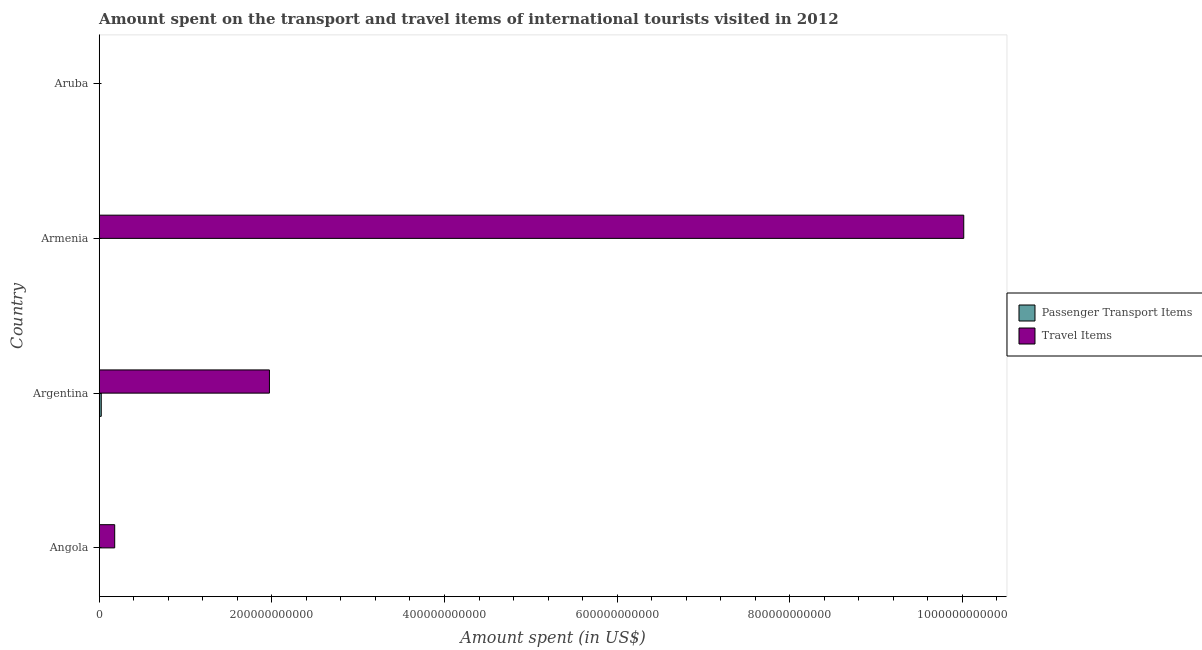How many different coloured bars are there?
Offer a terse response. 2. Are the number of bars per tick equal to the number of legend labels?
Your answer should be very brief. Yes. How many bars are there on the 4th tick from the bottom?
Ensure brevity in your answer.  2. What is the amount spent in travel items in Angola?
Offer a very short reply. 1.79e+1. Across all countries, what is the maximum amount spent in travel items?
Make the answer very short. 1.00e+12. Across all countries, what is the minimum amount spent in travel items?
Your answer should be compact. 7.50e+07. In which country was the amount spent in travel items maximum?
Give a very brief answer. Armenia. In which country was the amount spent in travel items minimum?
Ensure brevity in your answer.  Aruba. What is the total amount spent on passenger transport items in the graph?
Give a very brief answer. 2.57e+09. What is the difference between the amount spent in travel items in Angola and that in Aruba?
Your response must be concise. 1.79e+1. What is the difference between the amount spent on passenger transport items in Angola and the amount spent in travel items in Armenia?
Ensure brevity in your answer.  -1.00e+12. What is the average amount spent in travel items per country?
Your answer should be very brief. 3.04e+11. What is the difference between the amount spent on passenger transport items and amount spent in travel items in Armenia?
Ensure brevity in your answer.  -1.00e+12. What is the ratio of the amount spent on passenger transport items in Armenia to that in Aruba?
Provide a short and direct response. 3.74. Is the amount spent on passenger transport items in Angola less than that in Aruba?
Offer a terse response. No. Is the difference between the amount spent in travel items in Angola and Argentina greater than the difference between the amount spent on passenger transport items in Angola and Argentina?
Offer a very short reply. No. What is the difference between the highest and the second highest amount spent on passenger transport items?
Make the answer very short. 2.22e+09. What is the difference between the highest and the lowest amount spent in travel items?
Keep it short and to the point. 1.00e+12. In how many countries, is the amount spent in travel items greater than the average amount spent in travel items taken over all countries?
Provide a short and direct response. 1. Is the sum of the amount spent in travel items in Armenia and Aruba greater than the maximum amount spent on passenger transport items across all countries?
Keep it short and to the point. Yes. What does the 2nd bar from the top in Aruba represents?
Your response must be concise. Passenger Transport Items. What does the 1st bar from the bottom in Angola represents?
Provide a short and direct response. Passenger Transport Items. How many bars are there?
Your answer should be compact. 8. Are all the bars in the graph horizontal?
Ensure brevity in your answer.  Yes. What is the difference between two consecutive major ticks on the X-axis?
Your answer should be very brief. 2.00e+11. Are the values on the major ticks of X-axis written in scientific E-notation?
Offer a very short reply. No. Where does the legend appear in the graph?
Your response must be concise. Center right. How many legend labels are there?
Your response must be concise. 2. What is the title of the graph?
Give a very brief answer. Amount spent on the transport and travel items of international tourists visited in 2012. Does "Non-pregnant women" appear as one of the legend labels in the graph?
Provide a succinct answer. No. What is the label or title of the X-axis?
Make the answer very short. Amount spent (in US$). What is the label or title of the Y-axis?
Provide a short and direct response. Country. What is the Amount spent (in US$) of Passenger Transport Items in Angola?
Provide a short and direct response. 1.33e+08. What is the Amount spent (in US$) in Travel Items in Angola?
Your response must be concise. 1.79e+1. What is the Amount spent (in US$) of Passenger Transport Items in Argentina?
Offer a terse response. 2.35e+09. What is the Amount spent (in US$) in Travel Items in Argentina?
Make the answer very short. 1.97e+11. What is the Amount spent (in US$) in Passenger Transport Items in Armenia?
Your answer should be very brief. 7.10e+07. What is the Amount spent (in US$) of Travel Items in Armenia?
Your answer should be very brief. 1.00e+12. What is the Amount spent (in US$) in Passenger Transport Items in Aruba?
Offer a terse response. 1.90e+07. What is the Amount spent (in US$) in Travel Items in Aruba?
Keep it short and to the point. 7.50e+07. Across all countries, what is the maximum Amount spent (in US$) of Passenger Transport Items?
Provide a succinct answer. 2.35e+09. Across all countries, what is the maximum Amount spent (in US$) of Travel Items?
Provide a succinct answer. 1.00e+12. Across all countries, what is the minimum Amount spent (in US$) in Passenger Transport Items?
Make the answer very short. 1.90e+07. Across all countries, what is the minimum Amount spent (in US$) of Travel Items?
Provide a short and direct response. 7.50e+07. What is the total Amount spent (in US$) of Passenger Transport Items in the graph?
Provide a succinct answer. 2.57e+09. What is the total Amount spent (in US$) of Travel Items in the graph?
Offer a terse response. 1.22e+12. What is the difference between the Amount spent (in US$) in Passenger Transport Items in Angola and that in Argentina?
Your answer should be very brief. -2.22e+09. What is the difference between the Amount spent (in US$) in Travel Items in Angola and that in Argentina?
Provide a short and direct response. -1.79e+11. What is the difference between the Amount spent (in US$) of Passenger Transport Items in Angola and that in Armenia?
Offer a very short reply. 6.20e+07. What is the difference between the Amount spent (in US$) in Travel Items in Angola and that in Armenia?
Make the answer very short. -9.84e+11. What is the difference between the Amount spent (in US$) of Passenger Transport Items in Angola and that in Aruba?
Offer a terse response. 1.14e+08. What is the difference between the Amount spent (in US$) of Travel Items in Angola and that in Aruba?
Offer a terse response. 1.79e+1. What is the difference between the Amount spent (in US$) of Passenger Transport Items in Argentina and that in Armenia?
Ensure brevity in your answer.  2.28e+09. What is the difference between the Amount spent (in US$) in Travel Items in Argentina and that in Armenia?
Provide a succinct answer. -8.04e+11. What is the difference between the Amount spent (in US$) in Passenger Transport Items in Argentina and that in Aruba?
Provide a succinct answer. 2.33e+09. What is the difference between the Amount spent (in US$) in Travel Items in Argentina and that in Aruba?
Your response must be concise. 1.97e+11. What is the difference between the Amount spent (in US$) in Passenger Transport Items in Armenia and that in Aruba?
Offer a very short reply. 5.20e+07. What is the difference between the Amount spent (in US$) of Travel Items in Armenia and that in Aruba?
Offer a very short reply. 1.00e+12. What is the difference between the Amount spent (in US$) of Passenger Transport Items in Angola and the Amount spent (in US$) of Travel Items in Argentina?
Your response must be concise. -1.97e+11. What is the difference between the Amount spent (in US$) of Passenger Transport Items in Angola and the Amount spent (in US$) of Travel Items in Armenia?
Make the answer very short. -1.00e+12. What is the difference between the Amount spent (in US$) of Passenger Transport Items in Angola and the Amount spent (in US$) of Travel Items in Aruba?
Make the answer very short. 5.80e+07. What is the difference between the Amount spent (in US$) in Passenger Transport Items in Argentina and the Amount spent (in US$) in Travel Items in Armenia?
Make the answer very short. -9.99e+11. What is the difference between the Amount spent (in US$) of Passenger Transport Items in Argentina and the Amount spent (in US$) of Travel Items in Aruba?
Provide a succinct answer. 2.28e+09. What is the average Amount spent (in US$) of Passenger Transport Items per country?
Give a very brief answer. 6.43e+08. What is the average Amount spent (in US$) of Travel Items per country?
Make the answer very short. 3.04e+11. What is the difference between the Amount spent (in US$) of Passenger Transport Items and Amount spent (in US$) of Travel Items in Angola?
Your answer should be compact. -1.78e+1. What is the difference between the Amount spent (in US$) in Passenger Transport Items and Amount spent (in US$) in Travel Items in Argentina?
Your answer should be compact. -1.95e+11. What is the difference between the Amount spent (in US$) in Passenger Transport Items and Amount spent (in US$) in Travel Items in Armenia?
Ensure brevity in your answer.  -1.00e+12. What is the difference between the Amount spent (in US$) in Passenger Transport Items and Amount spent (in US$) in Travel Items in Aruba?
Your answer should be compact. -5.60e+07. What is the ratio of the Amount spent (in US$) of Passenger Transport Items in Angola to that in Argentina?
Your answer should be very brief. 0.06. What is the ratio of the Amount spent (in US$) of Travel Items in Angola to that in Argentina?
Your answer should be compact. 0.09. What is the ratio of the Amount spent (in US$) of Passenger Transport Items in Angola to that in Armenia?
Ensure brevity in your answer.  1.87. What is the ratio of the Amount spent (in US$) in Travel Items in Angola to that in Armenia?
Offer a terse response. 0.02. What is the ratio of the Amount spent (in US$) in Travel Items in Angola to that in Aruba?
Your answer should be compact. 239.23. What is the ratio of the Amount spent (in US$) of Passenger Transport Items in Argentina to that in Armenia?
Offer a very short reply. 33.1. What is the ratio of the Amount spent (in US$) in Travel Items in Argentina to that in Armenia?
Offer a very short reply. 0.2. What is the ratio of the Amount spent (in US$) in Passenger Transport Items in Argentina to that in Aruba?
Your answer should be compact. 123.68. What is the ratio of the Amount spent (in US$) in Travel Items in Argentina to that in Aruba?
Provide a succinct answer. 2629.55. What is the ratio of the Amount spent (in US$) of Passenger Transport Items in Armenia to that in Aruba?
Keep it short and to the point. 3.74. What is the ratio of the Amount spent (in US$) of Travel Items in Armenia to that in Aruba?
Your response must be concise. 1.34e+04. What is the difference between the highest and the second highest Amount spent (in US$) in Passenger Transport Items?
Your answer should be compact. 2.22e+09. What is the difference between the highest and the second highest Amount spent (in US$) of Travel Items?
Provide a succinct answer. 8.04e+11. What is the difference between the highest and the lowest Amount spent (in US$) in Passenger Transport Items?
Your answer should be compact. 2.33e+09. What is the difference between the highest and the lowest Amount spent (in US$) of Travel Items?
Your answer should be compact. 1.00e+12. 